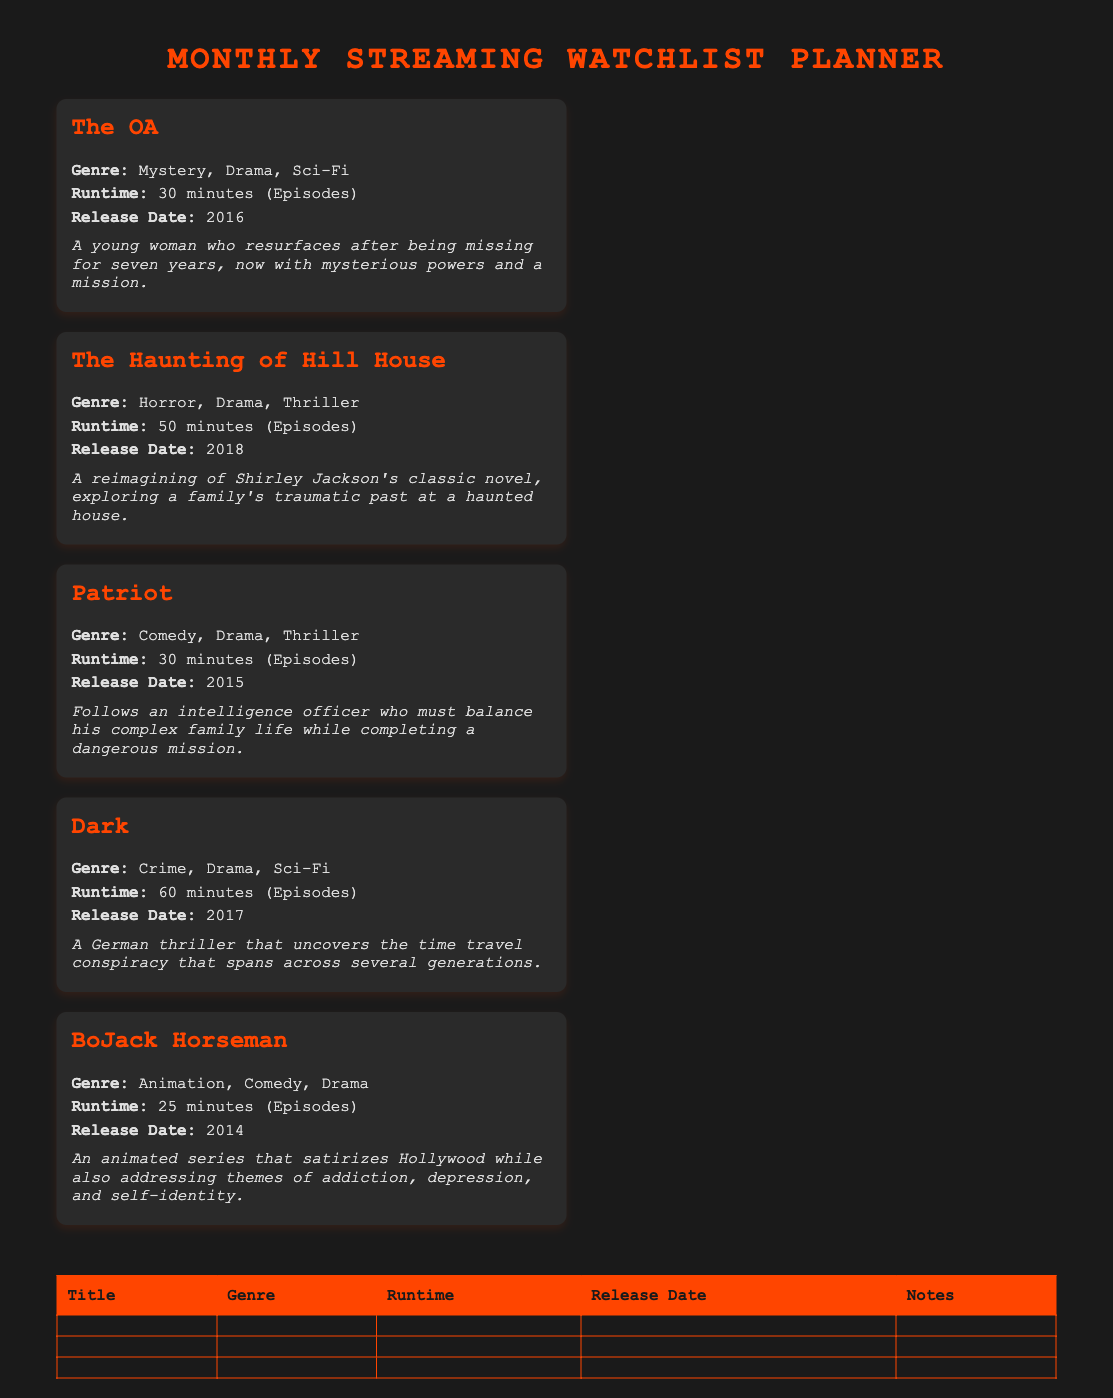What is the title of the show released in 2016? The title of the show released in 2016 is "The OA."
Answer: The OA Which show has a runtime of 50 minutes per episode? The show with a runtime of 50 minutes per episode is "The Haunting of Hill House."
Answer: The Haunting of Hill House How many episodes does "BoJack Horseman" have per episode runtime? "BoJack Horseman" has a runtime of 25 minutes per episode.
Answer: 25 minutes What genre does "Dark" belong to? "Dark" belongs to the genres of Crime, Drama, and Sci-Fi.
Answer: Crime, Drama, Sci-Fi Which series features an intelligence officer? The series that features an intelligence officer is "Patriot."
Answer: Patriot What is the release date of "The Haunting of Hill House"? The release date of "The Haunting of Hill House" is 2018.
Answer: 2018 Which show has the shortest episode runtime? The show with the shortest episode runtime is "BoJack Horseman."
Answer: BoJack Horseman What is the main theme of "The OA"? The main theme of "The OA" is about a young woman with mysterious powers.
Answer: Mysterious powers Which show is described as a satire of Hollywood? The show described as a satire of Hollywood is "BoJack Horseman."
Answer: BoJack Horseman 